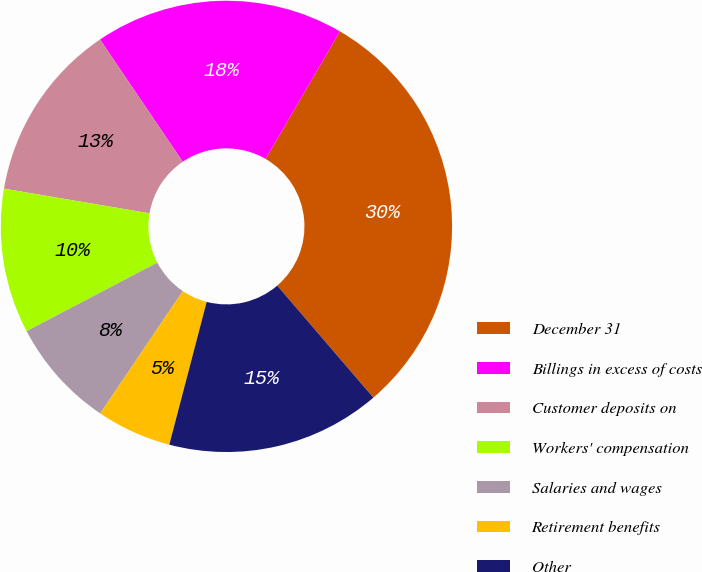Convert chart. <chart><loc_0><loc_0><loc_500><loc_500><pie_chart><fcel>December 31<fcel>Billings in excess of costs<fcel>Customer deposits on<fcel>Workers' compensation<fcel>Salaries and wages<fcel>Retirement benefits<fcel>Other<nl><fcel>30.33%<fcel>17.85%<fcel>12.86%<fcel>10.36%<fcel>7.87%<fcel>5.37%<fcel>15.36%<nl></chart> 